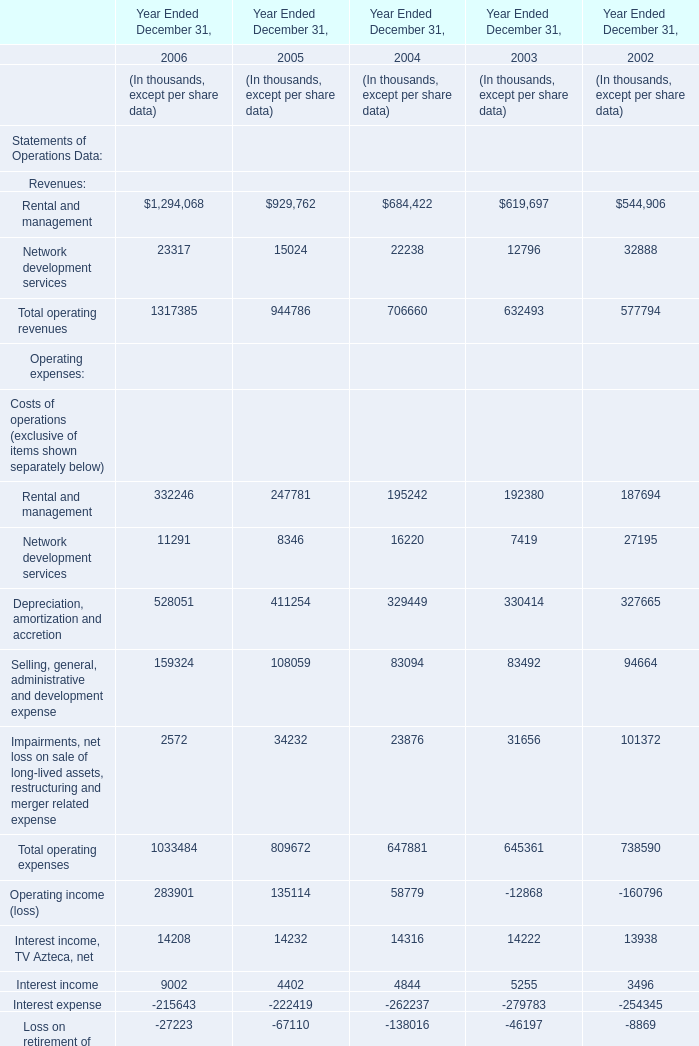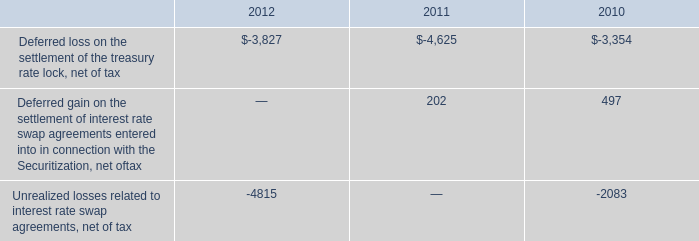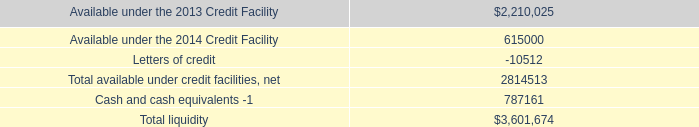what was the total reclassification of oci into income , in millions , during the years ended december 31 , 2012 , 2011 and 2010? 
Computations: (0.6 + 0.1)
Answer: 0.7. 